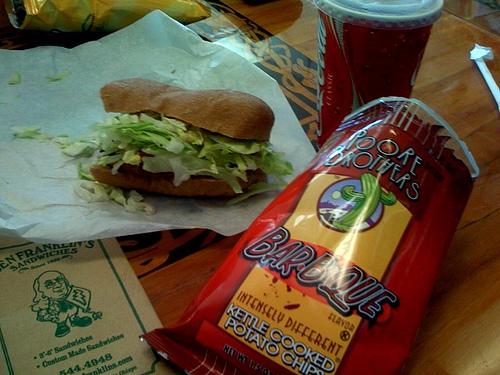What is the name of the Market?
Give a very brief answer. Poore brothers. Is there a menu shown?
Quick response, please. Yes. Is this a fast food restaurant?
Concise answer only. Yes. Was this all handmade?
Short answer required. No. What type of veggies are in the photo?
Answer briefly. Lettuce. Is there more than once sandwich on this scene?
Be succinct. No. What is in the bag?
Be succinct. Chips. What is beside the sandwich?
Keep it brief. Chips. Could this be a meal for two?
Give a very brief answer. No. What is in the cup?
Keep it brief. Soda. What brand chips are on the table?
Write a very short answer. Poore brothers. What is sitting right above the napkin?
Short answer required. Sandwich. How many cups?
Short answer required. 1. Is there a certain color spelled out in the photo?
Be succinct. No. What flavor chips are in the bag?
Concise answer only. Barbecue. What kind of chips are those?
Give a very brief answer. Barbecue. What is the name  of the chips that are on the table?
Write a very short answer. Poore brothers. What is pictured on the table beside a red cup?
Answer briefly. Sandwich. Where is the food from?
Concise answer only. Poore brothers. What kind of food is this?
Short answer required. Potato chips. 